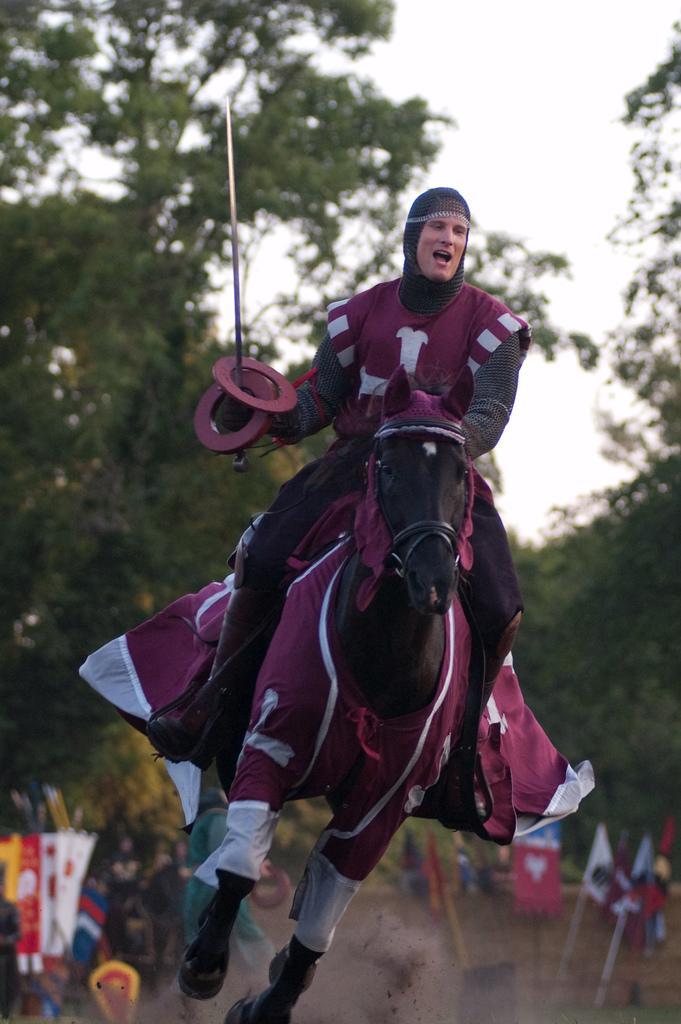Could you give a brief overview of what you see in this image? In this image we can see one man riding a horse in a ground and holds a big knife. There are some flags with poles, some objects are on the surface, some people are standing, some trees, bushes, plants and grass on the surface. At the top there is the sky. 